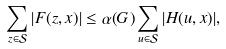<formula> <loc_0><loc_0><loc_500><loc_500>\sum _ { z \in \mathcal { S } } | F ( z , x ) | \leq \alpha ( G ) \sum _ { u \in \mathcal { S } } | H ( u , x ) | ,</formula> 